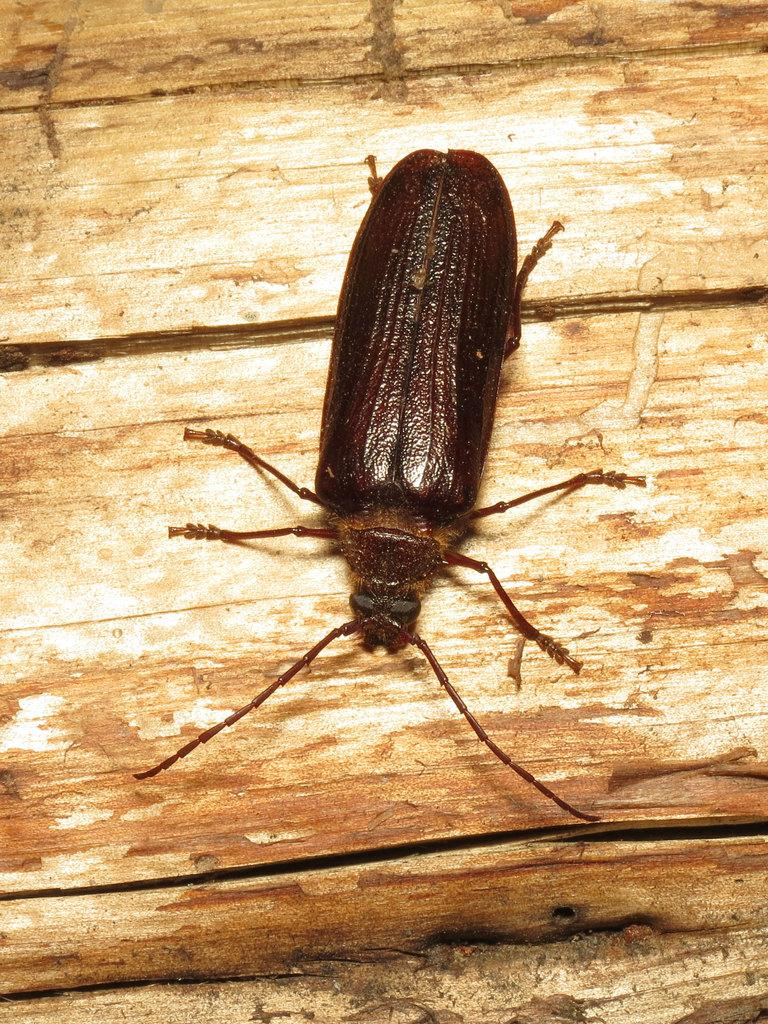What type of creature is in the image? There is an insect in the image. What color is the insect? The insect is brown in color. What is the insect resting on in the image? The insect is on a brown surface. Can you see any ghosts in the image? No, there are no ghosts present in the image. 